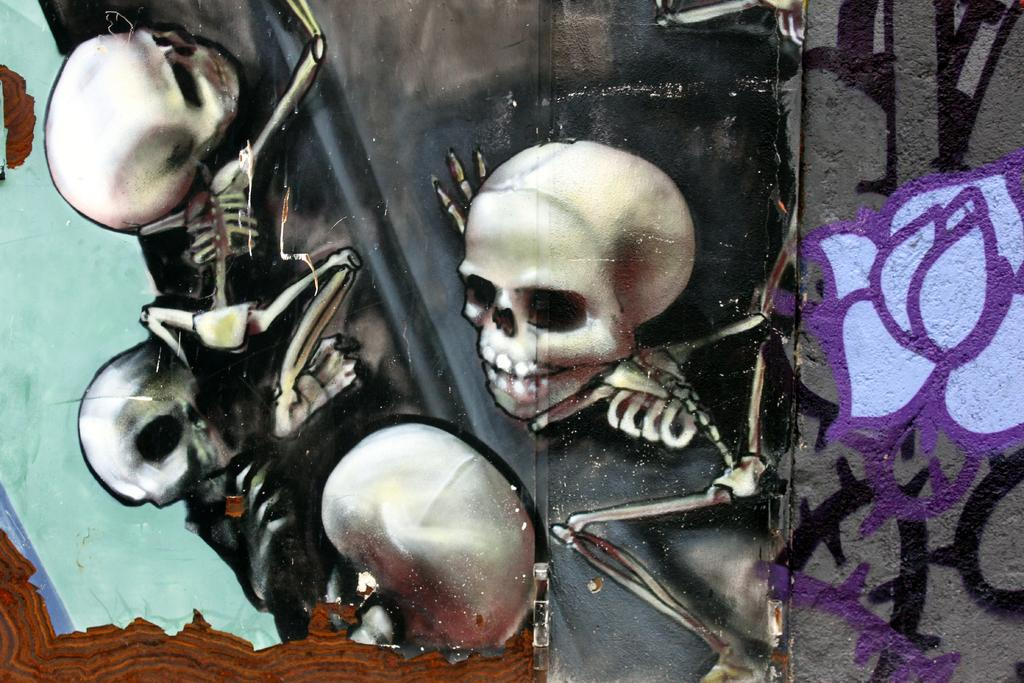What objects can be seen in the image? There are skulls in the image. What else is present in the image besides the skulls? There is a wall painting in the image. Can you describe the appearance of the wall painting? The wall painting is in purple and black color. What type of comb is being used to style the skulls in the image? There is no comb present in the image, and the skulls are not being styled. 